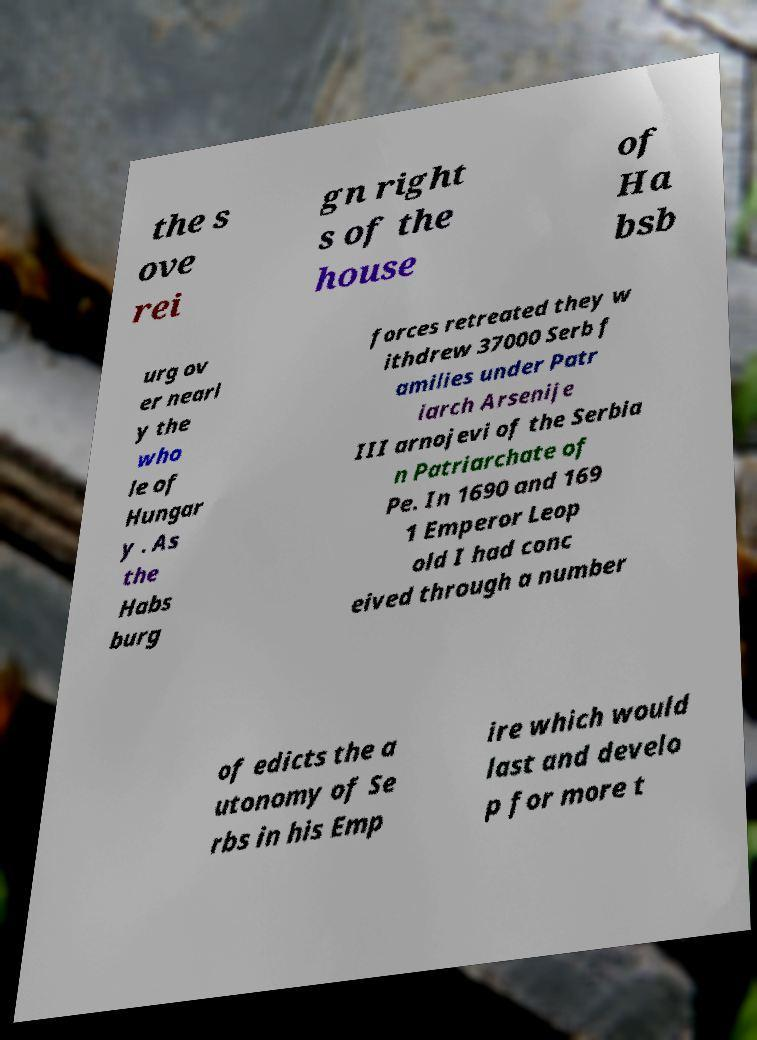Please identify and transcribe the text found in this image. the s ove rei gn right s of the house of Ha bsb urg ov er nearl y the who le of Hungar y . As the Habs burg forces retreated they w ithdrew 37000 Serb f amilies under Patr iarch Arsenije III arnojevi of the Serbia n Patriarchate of Pe. In 1690 and 169 1 Emperor Leop old I had conc eived through a number of edicts the a utonomy of Se rbs in his Emp ire which would last and develo p for more t 